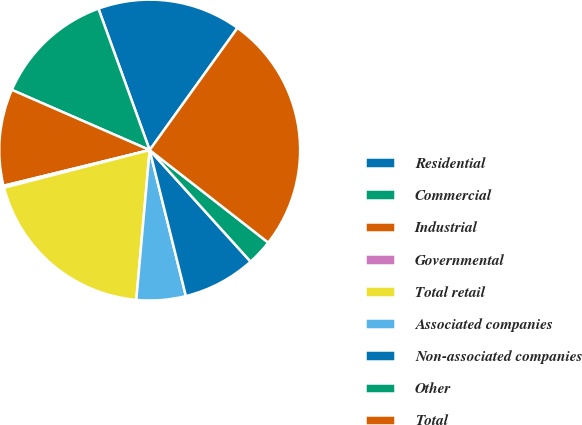<chart> <loc_0><loc_0><loc_500><loc_500><pie_chart><fcel>Residential<fcel>Commercial<fcel>Industrial<fcel>Governmental<fcel>Total retail<fcel>Associated companies<fcel>Non-associated companies<fcel>Other<fcel>Total<nl><fcel>15.45%<fcel>12.91%<fcel>10.37%<fcel>0.21%<fcel>19.55%<fcel>5.29%<fcel>7.83%<fcel>2.75%<fcel>25.62%<nl></chart> 